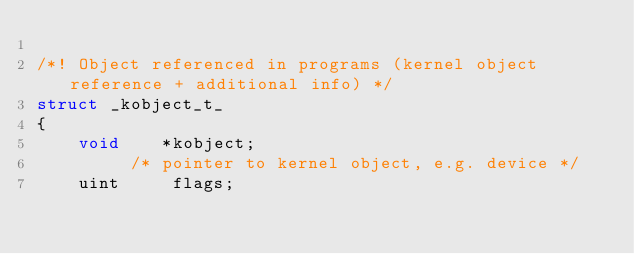<code> <loc_0><loc_0><loc_500><loc_500><_C_>
/*! Object referenced in programs (kernel object reference + additional info) */
struct _kobject_t_
{
	void	*kobject;
		 /* pointer to kernel object, e.g. device */
	uint	 flags;</code> 